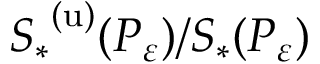Convert formula to latex. <formula><loc_0><loc_0><loc_500><loc_500>{ S _ { * } } ^ { ( u ) } ( P _ { \varepsilon } ) / S _ { * } ( P _ { \varepsilon } )</formula> 